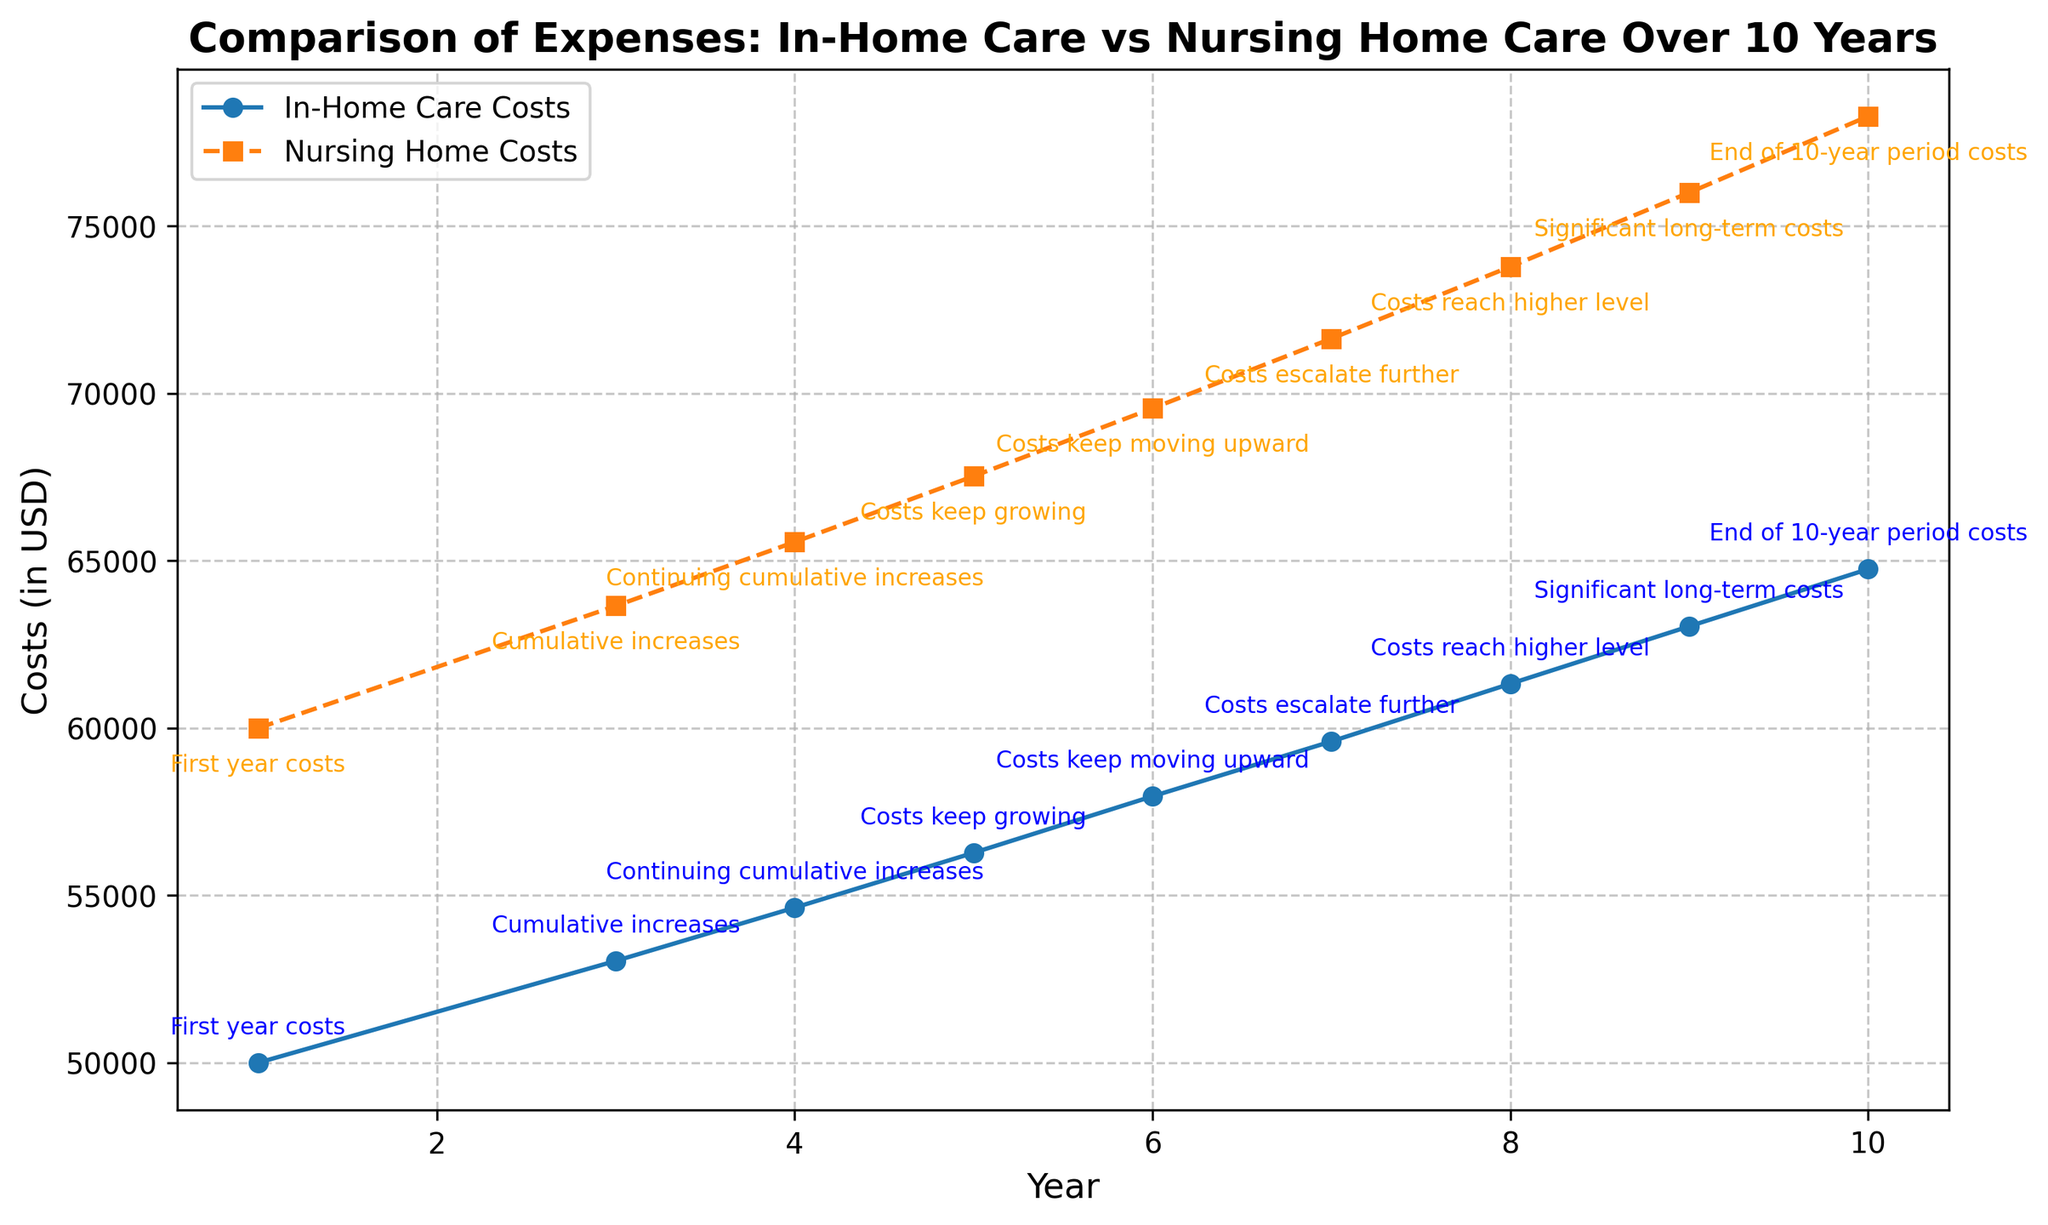What are the costs for in-home care and nursing home care in the first year? For the first year, refer to the data points at Year 1. The costs for in-home care are $50,000 and for nursing home care $60,000 from the plot annotations.
Answer: $50,000 for in-home care, $60,000 for nursing home care What is the cumulative increase in costs for nursing home care from Year 1 to Year 3? From the plot annotations, the initial cost in Year 1 is $60,000, and by Year 3, it has risen to $63,654. The increase is $63,654 - $60,000.
Answer: $3,654 Which year shows the highest increase in costs for both care types compared to the previous year? Compare each year’s costs with the previous year within the annotations; Year 9 has the highest jumps in costs for both categories compared to Year 8, as illustrated in the plot.
Answer: Year 9 By the end of the 10-year period, how much more costly is nursing home care compared to in-home care? From the plot, the costs in Year 10 are $64,752.72 for in-home care and $78,285.29 for nursing home care. Subtract the in-home care costs from nursing home care costs: $78,285.29 - $64,752.72.
Answer: $13,532.57 What does the cumulative trend suggest about the expenses of in-home care vs. nursing home care over the 10 years? Over the 10-year period, both costs increase steadily, but nursing home care consistently remains higher throughout based on the plotted trend lines and annotations. This indicates long-term greater expenses for nursing home care.
Answer: Nursing home care has higher expenses Which care type remains consistently more expensive over the 10-year period? From the plot, nursing home care costs remain consistently higher than in-home care costs throughout the entire 10 years.
Answer: Nursing home care What can you infer about the rate of increase in costs for both types of care from Year 5 to Year 10? By examining the plot annotations, in-home care costs increase from $56,275.44 to $64,752.72 and nursing home care from $67,530.53 to $78,285.29. Both costs increase, but nursing home care maintains a higher rate.
Answer: Both increase, nursing home higher What is the visual difference between the trend lines for in-home care and nursing home care costs over the years? The solid line represents in-home care costs, and the dashed line represents nursing home care. The dashed line is consistently above the solid line, indicating higher costs for nursing home care.
Answer: Dashed line above solid line At what point do the costs for both care types diverge the most? Observing the plots, the highest divergence visually appears towards the end of the period at Year 10, where the gap in costs between in-home care and nursing home care is the widest.
Answer: Year 10 What are the overall trends in the annotations about the expenses plotted in the graph? Annotations mention cumulative increases and costs escalating further, indicating that both in-home care and nursing home care experiences steady increases in costs over time. However, the nursing home care costs rise at a higher rate.
Answer: Steady increase, nursing home rises faster 